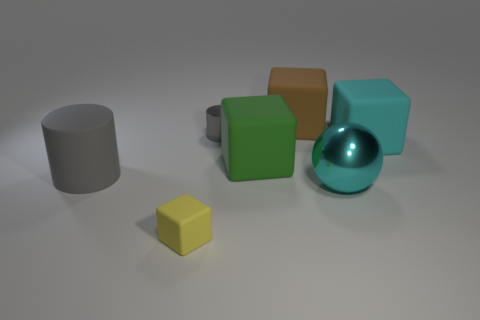Can you describe the arrangement of objects in this image? In the image, the objects are arranged casually on a flat surface. To the left, there is a standalone gray cylinder. In the center, an assortment of three cubes - brown, green, and teal - are clustered together. Adjacent to this grouping, on the right, there is a cyan sphere right of the gray cylinder. In the foreground, offset to the left, is a small yellow cube, providing a contrasting color highlight. 